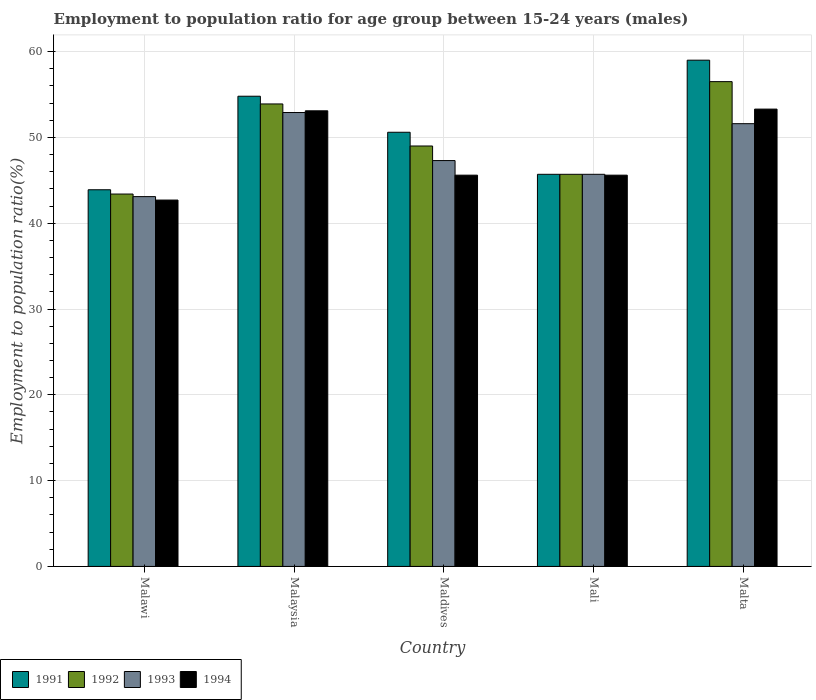How many bars are there on the 4th tick from the left?
Your response must be concise. 4. What is the label of the 5th group of bars from the left?
Ensure brevity in your answer.  Malta. What is the employment to population ratio in 1993 in Malta?
Offer a terse response. 51.6. Across all countries, what is the maximum employment to population ratio in 1993?
Offer a very short reply. 52.9. Across all countries, what is the minimum employment to population ratio in 1992?
Offer a very short reply. 43.4. In which country was the employment to population ratio in 1994 maximum?
Your answer should be compact. Malta. In which country was the employment to population ratio in 1993 minimum?
Provide a short and direct response. Malawi. What is the total employment to population ratio in 1994 in the graph?
Provide a succinct answer. 240.3. What is the difference between the employment to population ratio in 1993 in Maldives and that in Mali?
Offer a terse response. 1.6. What is the difference between the employment to population ratio in 1994 in Malta and the employment to population ratio in 1992 in Malawi?
Provide a succinct answer. 9.9. What is the average employment to population ratio in 1992 per country?
Offer a terse response. 49.7. What is the difference between the employment to population ratio of/in 1991 and employment to population ratio of/in 1993 in Malawi?
Ensure brevity in your answer.  0.8. What is the ratio of the employment to population ratio in 1994 in Maldives to that in Malta?
Offer a very short reply. 0.86. Is the difference between the employment to population ratio in 1991 in Malaysia and Maldives greater than the difference between the employment to population ratio in 1993 in Malaysia and Maldives?
Give a very brief answer. No. What is the difference between the highest and the second highest employment to population ratio in 1991?
Ensure brevity in your answer.  -8.4. What is the difference between the highest and the lowest employment to population ratio in 1993?
Provide a succinct answer. 9.8. Is the sum of the employment to population ratio in 1991 in Malaysia and Mali greater than the maximum employment to population ratio in 1993 across all countries?
Offer a very short reply. Yes. What does the 1st bar from the left in Maldives represents?
Provide a succinct answer. 1991. What does the 3rd bar from the right in Mali represents?
Give a very brief answer. 1992. How many bars are there?
Offer a terse response. 20. Are all the bars in the graph horizontal?
Your response must be concise. No. How many countries are there in the graph?
Your answer should be compact. 5. What is the difference between two consecutive major ticks on the Y-axis?
Keep it short and to the point. 10. Does the graph contain grids?
Your response must be concise. Yes. Where does the legend appear in the graph?
Your answer should be very brief. Bottom left. How are the legend labels stacked?
Keep it short and to the point. Horizontal. What is the title of the graph?
Your answer should be very brief. Employment to population ratio for age group between 15-24 years (males). Does "2005" appear as one of the legend labels in the graph?
Offer a terse response. No. What is the label or title of the X-axis?
Make the answer very short. Country. What is the Employment to population ratio(%) in 1991 in Malawi?
Provide a succinct answer. 43.9. What is the Employment to population ratio(%) of 1992 in Malawi?
Offer a very short reply. 43.4. What is the Employment to population ratio(%) of 1993 in Malawi?
Keep it short and to the point. 43.1. What is the Employment to population ratio(%) of 1994 in Malawi?
Your response must be concise. 42.7. What is the Employment to population ratio(%) of 1991 in Malaysia?
Your answer should be very brief. 54.8. What is the Employment to population ratio(%) in 1992 in Malaysia?
Offer a terse response. 53.9. What is the Employment to population ratio(%) in 1993 in Malaysia?
Keep it short and to the point. 52.9. What is the Employment to population ratio(%) in 1994 in Malaysia?
Keep it short and to the point. 53.1. What is the Employment to population ratio(%) of 1991 in Maldives?
Make the answer very short. 50.6. What is the Employment to population ratio(%) of 1992 in Maldives?
Your answer should be very brief. 49. What is the Employment to population ratio(%) in 1993 in Maldives?
Ensure brevity in your answer.  47.3. What is the Employment to population ratio(%) in 1994 in Maldives?
Your answer should be compact. 45.6. What is the Employment to population ratio(%) in 1991 in Mali?
Make the answer very short. 45.7. What is the Employment to population ratio(%) in 1992 in Mali?
Provide a short and direct response. 45.7. What is the Employment to population ratio(%) of 1993 in Mali?
Your response must be concise. 45.7. What is the Employment to population ratio(%) of 1994 in Mali?
Offer a very short reply. 45.6. What is the Employment to population ratio(%) of 1991 in Malta?
Give a very brief answer. 59. What is the Employment to population ratio(%) of 1992 in Malta?
Your answer should be very brief. 56.5. What is the Employment to population ratio(%) in 1993 in Malta?
Your answer should be very brief. 51.6. What is the Employment to population ratio(%) in 1994 in Malta?
Make the answer very short. 53.3. Across all countries, what is the maximum Employment to population ratio(%) of 1991?
Make the answer very short. 59. Across all countries, what is the maximum Employment to population ratio(%) of 1992?
Provide a short and direct response. 56.5. Across all countries, what is the maximum Employment to population ratio(%) of 1993?
Your response must be concise. 52.9. Across all countries, what is the maximum Employment to population ratio(%) of 1994?
Offer a very short reply. 53.3. Across all countries, what is the minimum Employment to population ratio(%) in 1991?
Offer a very short reply. 43.9. Across all countries, what is the minimum Employment to population ratio(%) in 1992?
Provide a short and direct response. 43.4. Across all countries, what is the minimum Employment to population ratio(%) of 1993?
Make the answer very short. 43.1. Across all countries, what is the minimum Employment to population ratio(%) of 1994?
Offer a terse response. 42.7. What is the total Employment to population ratio(%) in 1991 in the graph?
Keep it short and to the point. 254. What is the total Employment to population ratio(%) of 1992 in the graph?
Your response must be concise. 248.5. What is the total Employment to population ratio(%) of 1993 in the graph?
Your response must be concise. 240.6. What is the total Employment to population ratio(%) of 1994 in the graph?
Make the answer very short. 240.3. What is the difference between the Employment to population ratio(%) of 1992 in Malawi and that in Malaysia?
Provide a short and direct response. -10.5. What is the difference between the Employment to population ratio(%) in 1993 in Malawi and that in Malaysia?
Your answer should be very brief. -9.8. What is the difference between the Employment to population ratio(%) of 1994 in Malawi and that in Mali?
Your response must be concise. -2.9. What is the difference between the Employment to population ratio(%) of 1991 in Malawi and that in Malta?
Offer a very short reply. -15.1. What is the difference between the Employment to population ratio(%) of 1992 in Malawi and that in Malta?
Your answer should be compact. -13.1. What is the difference between the Employment to population ratio(%) of 1994 in Malawi and that in Malta?
Provide a short and direct response. -10.6. What is the difference between the Employment to population ratio(%) in 1991 in Malaysia and that in Malta?
Your answer should be very brief. -4.2. What is the difference between the Employment to population ratio(%) of 1992 in Malaysia and that in Malta?
Make the answer very short. -2.6. What is the difference between the Employment to population ratio(%) in 1993 in Malaysia and that in Malta?
Ensure brevity in your answer.  1.3. What is the difference between the Employment to population ratio(%) of 1992 in Maldives and that in Malta?
Offer a very short reply. -7.5. What is the difference between the Employment to population ratio(%) in 1991 in Mali and that in Malta?
Give a very brief answer. -13.3. What is the difference between the Employment to population ratio(%) of 1992 in Mali and that in Malta?
Make the answer very short. -10.8. What is the difference between the Employment to population ratio(%) in 1991 in Malawi and the Employment to population ratio(%) in 1992 in Malaysia?
Your response must be concise. -10. What is the difference between the Employment to population ratio(%) of 1991 in Malawi and the Employment to population ratio(%) of 1993 in Malaysia?
Your response must be concise. -9. What is the difference between the Employment to population ratio(%) in 1992 in Malawi and the Employment to population ratio(%) in 1993 in Malaysia?
Make the answer very short. -9.5. What is the difference between the Employment to population ratio(%) in 1993 in Malawi and the Employment to population ratio(%) in 1994 in Malaysia?
Your answer should be compact. -10. What is the difference between the Employment to population ratio(%) in 1991 in Malawi and the Employment to population ratio(%) in 1992 in Maldives?
Give a very brief answer. -5.1. What is the difference between the Employment to population ratio(%) of 1992 in Malawi and the Employment to population ratio(%) of 1993 in Maldives?
Provide a succinct answer. -3.9. What is the difference between the Employment to population ratio(%) in 1992 in Malawi and the Employment to population ratio(%) in 1994 in Maldives?
Your answer should be compact. -2.2. What is the difference between the Employment to population ratio(%) of 1991 in Malawi and the Employment to population ratio(%) of 1993 in Mali?
Your response must be concise. -1.8. What is the difference between the Employment to population ratio(%) of 1992 in Malawi and the Employment to population ratio(%) of 1993 in Mali?
Your answer should be compact. -2.3. What is the difference between the Employment to population ratio(%) in 1992 in Malawi and the Employment to population ratio(%) in 1993 in Malta?
Provide a succinct answer. -8.2. What is the difference between the Employment to population ratio(%) of 1993 in Malawi and the Employment to population ratio(%) of 1994 in Malta?
Your response must be concise. -10.2. What is the difference between the Employment to population ratio(%) of 1993 in Malaysia and the Employment to population ratio(%) of 1994 in Maldives?
Your response must be concise. 7.3. What is the difference between the Employment to population ratio(%) in 1991 in Malaysia and the Employment to population ratio(%) in 1992 in Mali?
Keep it short and to the point. 9.1. What is the difference between the Employment to population ratio(%) of 1991 in Malaysia and the Employment to population ratio(%) of 1993 in Mali?
Keep it short and to the point. 9.1. What is the difference between the Employment to population ratio(%) in 1992 in Malaysia and the Employment to population ratio(%) in 1993 in Mali?
Offer a terse response. 8.2. What is the difference between the Employment to population ratio(%) of 1993 in Malaysia and the Employment to population ratio(%) of 1994 in Mali?
Keep it short and to the point. 7.3. What is the difference between the Employment to population ratio(%) of 1991 in Malaysia and the Employment to population ratio(%) of 1993 in Malta?
Your response must be concise. 3.2. What is the difference between the Employment to population ratio(%) of 1991 in Malaysia and the Employment to population ratio(%) of 1994 in Malta?
Offer a very short reply. 1.5. What is the difference between the Employment to population ratio(%) in 1991 in Maldives and the Employment to population ratio(%) in 1993 in Mali?
Your answer should be compact. 4.9. What is the difference between the Employment to population ratio(%) in 1993 in Maldives and the Employment to population ratio(%) in 1994 in Mali?
Provide a succinct answer. 1.7. What is the difference between the Employment to population ratio(%) in 1991 in Maldives and the Employment to population ratio(%) in 1993 in Malta?
Make the answer very short. -1. What is the difference between the Employment to population ratio(%) of 1992 in Maldives and the Employment to population ratio(%) of 1993 in Malta?
Make the answer very short. -2.6. What is the difference between the Employment to population ratio(%) in 1993 in Maldives and the Employment to population ratio(%) in 1994 in Malta?
Your answer should be very brief. -6. What is the difference between the Employment to population ratio(%) of 1991 in Mali and the Employment to population ratio(%) of 1993 in Malta?
Your response must be concise. -5.9. What is the difference between the Employment to population ratio(%) of 1992 in Mali and the Employment to population ratio(%) of 1994 in Malta?
Your response must be concise. -7.6. What is the difference between the Employment to population ratio(%) in 1993 in Mali and the Employment to population ratio(%) in 1994 in Malta?
Keep it short and to the point. -7.6. What is the average Employment to population ratio(%) of 1991 per country?
Your answer should be compact. 50.8. What is the average Employment to population ratio(%) in 1992 per country?
Make the answer very short. 49.7. What is the average Employment to population ratio(%) in 1993 per country?
Offer a terse response. 48.12. What is the average Employment to population ratio(%) of 1994 per country?
Your response must be concise. 48.06. What is the difference between the Employment to population ratio(%) of 1991 and Employment to population ratio(%) of 1994 in Malawi?
Your response must be concise. 1.2. What is the difference between the Employment to population ratio(%) in 1992 and Employment to population ratio(%) in 1993 in Malawi?
Give a very brief answer. 0.3. What is the difference between the Employment to population ratio(%) of 1992 and Employment to population ratio(%) of 1994 in Malawi?
Offer a very short reply. 0.7. What is the difference between the Employment to population ratio(%) in 1993 and Employment to population ratio(%) in 1994 in Malawi?
Your response must be concise. 0.4. What is the difference between the Employment to population ratio(%) in 1991 and Employment to population ratio(%) in 1994 in Malaysia?
Give a very brief answer. 1.7. What is the difference between the Employment to population ratio(%) of 1992 and Employment to population ratio(%) of 1994 in Malaysia?
Provide a succinct answer. 0.8. What is the difference between the Employment to population ratio(%) in 1991 and Employment to population ratio(%) in 1992 in Maldives?
Your answer should be very brief. 1.6. What is the difference between the Employment to population ratio(%) of 1992 and Employment to population ratio(%) of 1994 in Maldives?
Provide a succinct answer. 3.4. What is the difference between the Employment to population ratio(%) in 1993 and Employment to population ratio(%) in 1994 in Maldives?
Keep it short and to the point. 1.7. What is the difference between the Employment to population ratio(%) in 1991 and Employment to population ratio(%) in 1993 in Mali?
Provide a short and direct response. 0. What is the difference between the Employment to population ratio(%) of 1991 and Employment to population ratio(%) of 1994 in Mali?
Ensure brevity in your answer.  0.1. What is the difference between the Employment to population ratio(%) in 1992 and Employment to population ratio(%) in 1993 in Mali?
Your answer should be very brief. 0. What is the difference between the Employment to population ratio(%) in 1992 and Employment to population ratio(%) in 1994 in Mali?
Your response must be concise. 0.1. What is the difference between the Employment to population ratio(%) in 1993 and Employment to population ratio(%) in 1994 in Mali?
Your response must be concise. 0.1. What is the difference between the Employment to population ratio(%) of 1991 and Employment to population ratio(%) of 1993 in Malta?
Your answer should be compact. 7.4. What is the difference between the Employment to population ratio(%) of 1992 and Employment to population ratio(%) of 1993 in Malta?
Provide a succinct answer. 4.9. What is the difference between the Employment to population ratio(%) in 1993 and Employment to population ratio(%) in 1994 in Malta?
Keep it short and to the point. -1.7. What is the ratio of the Employment to population ratio(%) in 1991 in Malawi to that in Malaysia?
Keep it short and to the point. 0.8. What is the ratio of the Employment to population ratio(%) of 1992 in Malawi to that in Malaysia?
Provide a short and direct response. 0.81. What is the ratio of the Employment to population ratio(%) of 1993 in Malawi to that in Malaysia?
Offer a terse response. 0.81. What is the ratio of the Employment to population ratio(%) of 1994 in Malawi to that in Malaysia?
Your answer should be compact. 0.8. What is the ratio of the Employment to population ratio(%) of 1991 in Malawi to that in Maldives?
Offer a terse response. 0.87. What is the ratio of the Employment to population ratio(%) of 1992 in Malawi to that in Maldives?
Your answer should be compact. 0.89. What is the ratio of the Employment to population ratio(%) of 1993 in Malawi to that in Maldives?
Provide a succinct answer. 0.91. What is the ratio of the Employment to population ratio(%) in 1994 in Malawi to that in Maldives?
Ensure brevity in your answer.  0.94. What is the ratio of the Employment to population ratio(%) of 1991 in Malawi to that in Mali?
Your answer should be compact. 0.96. What is the ratio of the Employment to population ratio(%) in 1992 in Malawi to that in Mali?
Your response must be concise. 0.95. What is the ratio of the Employment to population ratio(%) in 1993 in Malawi to that in Mali?
Your answer should be very brief. 0.94. What is the ratio of the Employment to population ratio(%) of 1994 in Malawi to that in Mali?
Keep it short and to the point. 0.94. What is the ratio of the Employment to population ratio(%) of 1991 in Malawi to that in Malta?
Provide a succinct answer. 0.74. What is the ratio of the Employment to population ratio(%) in 1992 in Malawi to that in Malta?
Your answer should be very brief. 0.77. What is the ratio of the Employment to population ratio(%) in 1993 in Malawi to that in Malta?
Keep it short and to the point. 0.84. What is the ratio of the Employment to population ratio(%) of 1994 in Malawi to that in Malta?
Your answer should be very brief. 0.8. What is the ratio of the Employment to population ratio(%) of 1991 in Malaysia to that in Maldives?
Ensure brevity in your answer.  1.08. What is the ratio of the Employment to population ratio(%) of 1993 in Malaysia to that in Maldives?
Give a very brief answer. 1.12. What is the ratio of the Employment to population ratio(%) in 1994 in Malaysia to that in Maldives?
Give a very brief answer. 1.16. What is the ratio of the Employment to population ratio(%) in 1991 in Malaysia to that in Mali?
Offer a very short reply. 1.2. What is the ratio of the Employment to population ratio(%) in 1992 in Malaysia to that in Mali?
Your answer should be very brief. 1.18. What is the ratio of the Employment to population ratio(%) in 1993 in Malaysia to that in Mali?
Ensure brevity in your answer.  1.16. What is the ratio of the Employment to population ratio(%) in 1994 in Malaysia to that in Mali?
Your answer should be compact. 1.16. What is the ratio of the Employment to population ratio(%) in 1991 in Malaysia to that in Malta?
Your answer should be very brief. 0.93. What is the ratio of the Employment to population ratio(%) in 1992 in Malaysia to that in Malta?
Offer a very short reply. 0.95. What is the ratio of the Employment to population ratio(%) in 1993 in Malaysia to that in Malta?
Your answer should be compact. 1.03. What is the ratio of the Employment to population ratio(%) in 1994 in Malaysia to that in Malta?
Keep it short and to the point. 1. What is the ratio of the Employment to population ratio(%) in 1991 in Maldives to that in Mali?
Provide a succinct answer. 1.11. What is the ratio of the Employment to population ratio(%) of 1992 in Maldives to that in Mali?
Your response must be concise. 1.07. What is the ratio of the Employment to population ratio(%) of 1993 in Maldives to that in Mali?
Your answer should be compact. 1.03. What is the ratio of the Employment to population ratio(%) in 1991 in Maldives to that in Malta?
Ensure brevity in your answer.  0.86. What is the ratio of the Employment to population ratio(%) in 1992 in Maldives to that in Malta?
Your answer should be very brief. 0.87. What is the ratio of the Employment to population ratio(%) of 1993 in Maldives to that in Malta?
Ensure brevity in your answer.  0.92. What is the ratio of the Employment to population ratio(%) in 1994 in Maldives to that in Malta?
Your answer should be very brief. 0.86. What is the ratio of the Employment to population ratio(%) in 1991 in Mali to that in Malta?
Provide a short and direct response. 0.77. What is the ratio of the Employment to population ratio(%) of 1992 in Mali to that in Malta?
Provide a short and direct response. 0.81. What is the ratio of the Employment to population ratio(%) in 1993 in Mali to that in Malta?
Provide a succinct answer. 0.89. What is the ratio of the Employment to population ratio(%) in 1994 in Mali to that in Malta?
Ensure brevity in your answer.  0.86. What is the difference between the highest and the lowest Employment to population ratio(%) of 1992?
Your response must be concise. 13.1. What is the difference between the highest and the lowest Employment to population ratio(%) in 1994?
Provide a short and direct response. 10.6. 